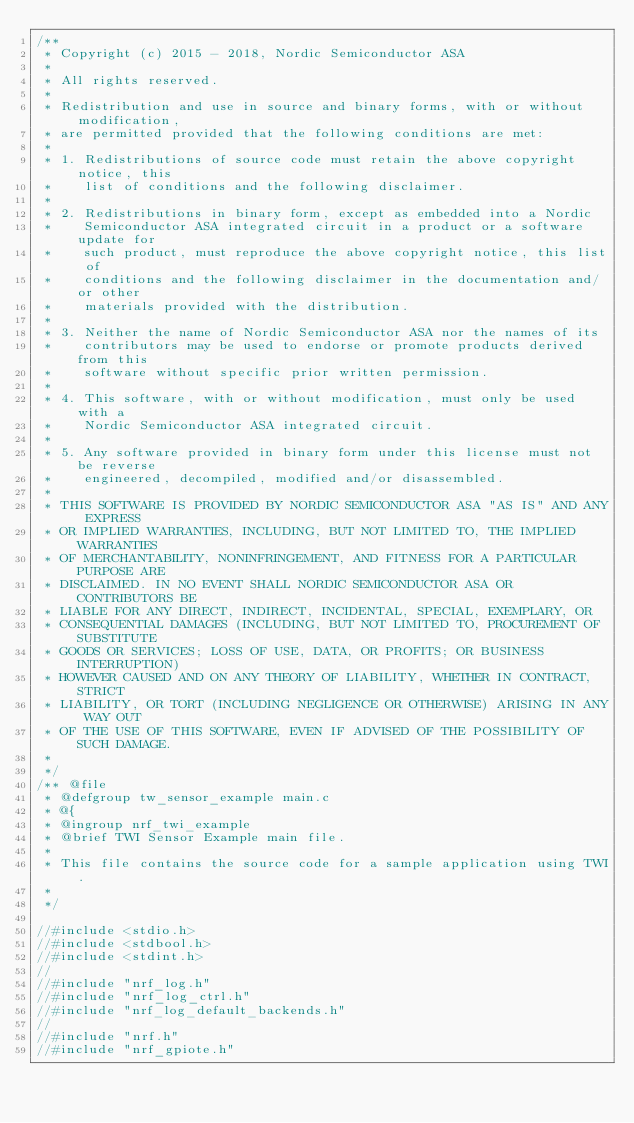Convert code to text. <code><loc_0><loc_0><loc_500><loc_500><_C_>/**
 * Copyright (c) 2015 - 2018, Nordic Semiconductor ASA
 *
 * All rights reserved.
 *
 * Redistribution and use in source and binary forms, with or without modification,
 * are permitted provided that the following conditions are met:
 *
 * 1. Redistributions of source code must retain the above copyright notice, this
 *    list of conditions and the following disclaimer.
 *
 * 2. Redistributions in binary form, except as embedded into a Nordic
 *    Semiconductor ASA integrated circuit in a product or a software update for
 *    such product, must reproduce the above copyright notice, this list of
 *    conditions and the following disclaimer in the documentation and/or other
 *    materials provided with the distribution.
 *
 * 3. Neither the name of Nordic Semiconductor ASA nor the names of its
 *    contributors may be used to endorse or promote products derived from this
 *    software without specific prior written permission.
 *
 * 4. This software, with or without modification, must only be used with a
 *    Nordic Semiconductor ASA integrated circuit.
 *
 * 5. Any software provided in binary form under this license must not be reverse
 *    engineered, decompiled, modified and/or disassembled.
 *
 * THIS SOFTWARE IS PROVIDED BY NORDIC SEMICONDUCTOR ASA "AS IS" AND ANY EXPRESS
 * OR IMPLIED WARRANTIES, INCLUDING, BUT NOT LIMITED TO, THE IMPLIED WARRANTIES
 * OF MERCHANTABILITY, NONINFRINGEMENT, AND FITNESS FOR A PARTICULAR PURPOSE ARE
 * DISCLAIMED. IN NO EVENT SHALL NORDIC SEMICONDUCTOR ASA OR CONTRIBUTORS BE
 * LIABLE FOR ANY DIRECT, INDIRECT, INCIDENTAL, SPECIAL, EXEMPLARY, OR
 * CONSEQUENTIAL DAMAGES (INCLUDING, BUT NOT LIMITED TO, PROCUREMENT OF SUBSTITUTE
 * GOODS OR SERVICES; LOSS OF USE, DATA, OR PROFITS; OR BUSINESS INTERRUPTION)
 * HOWEVER CAUSED AND ON ANY THEORY OF LIABILITY, WHETHER IN CONTRACT, STRICT
 * LIABILITY, OR TORT (INCLUDING NEGLIGENCE OR OTHERWISE) ARISING IN ANY WAY OUT
 * OF THE USE OF THIS SOFTWARE, EVEN IF ADVISED OF THE POSSIBILITY OF SUCH DAMAGE.
 *
 */
/** @file
 * @defgroup tw_sensor_example main.c
 * @{
 * @ingroup nrf_twi_example
 * @brief TWI Sensor Example main file.
 *
 * This file contains the source code for a sample application using TWI.
 *
 */

//#include <stdio.h>
//#include <stdbool.h>
//#include <stdint.h>
//
//#include "nrf_log.h"
//#include "nrf_log_ctrl.h"
//#include "nrf_log_default_backends.h"
//
//#include "nrf.h"
//#include "nrf_gpiote.h"</code> 